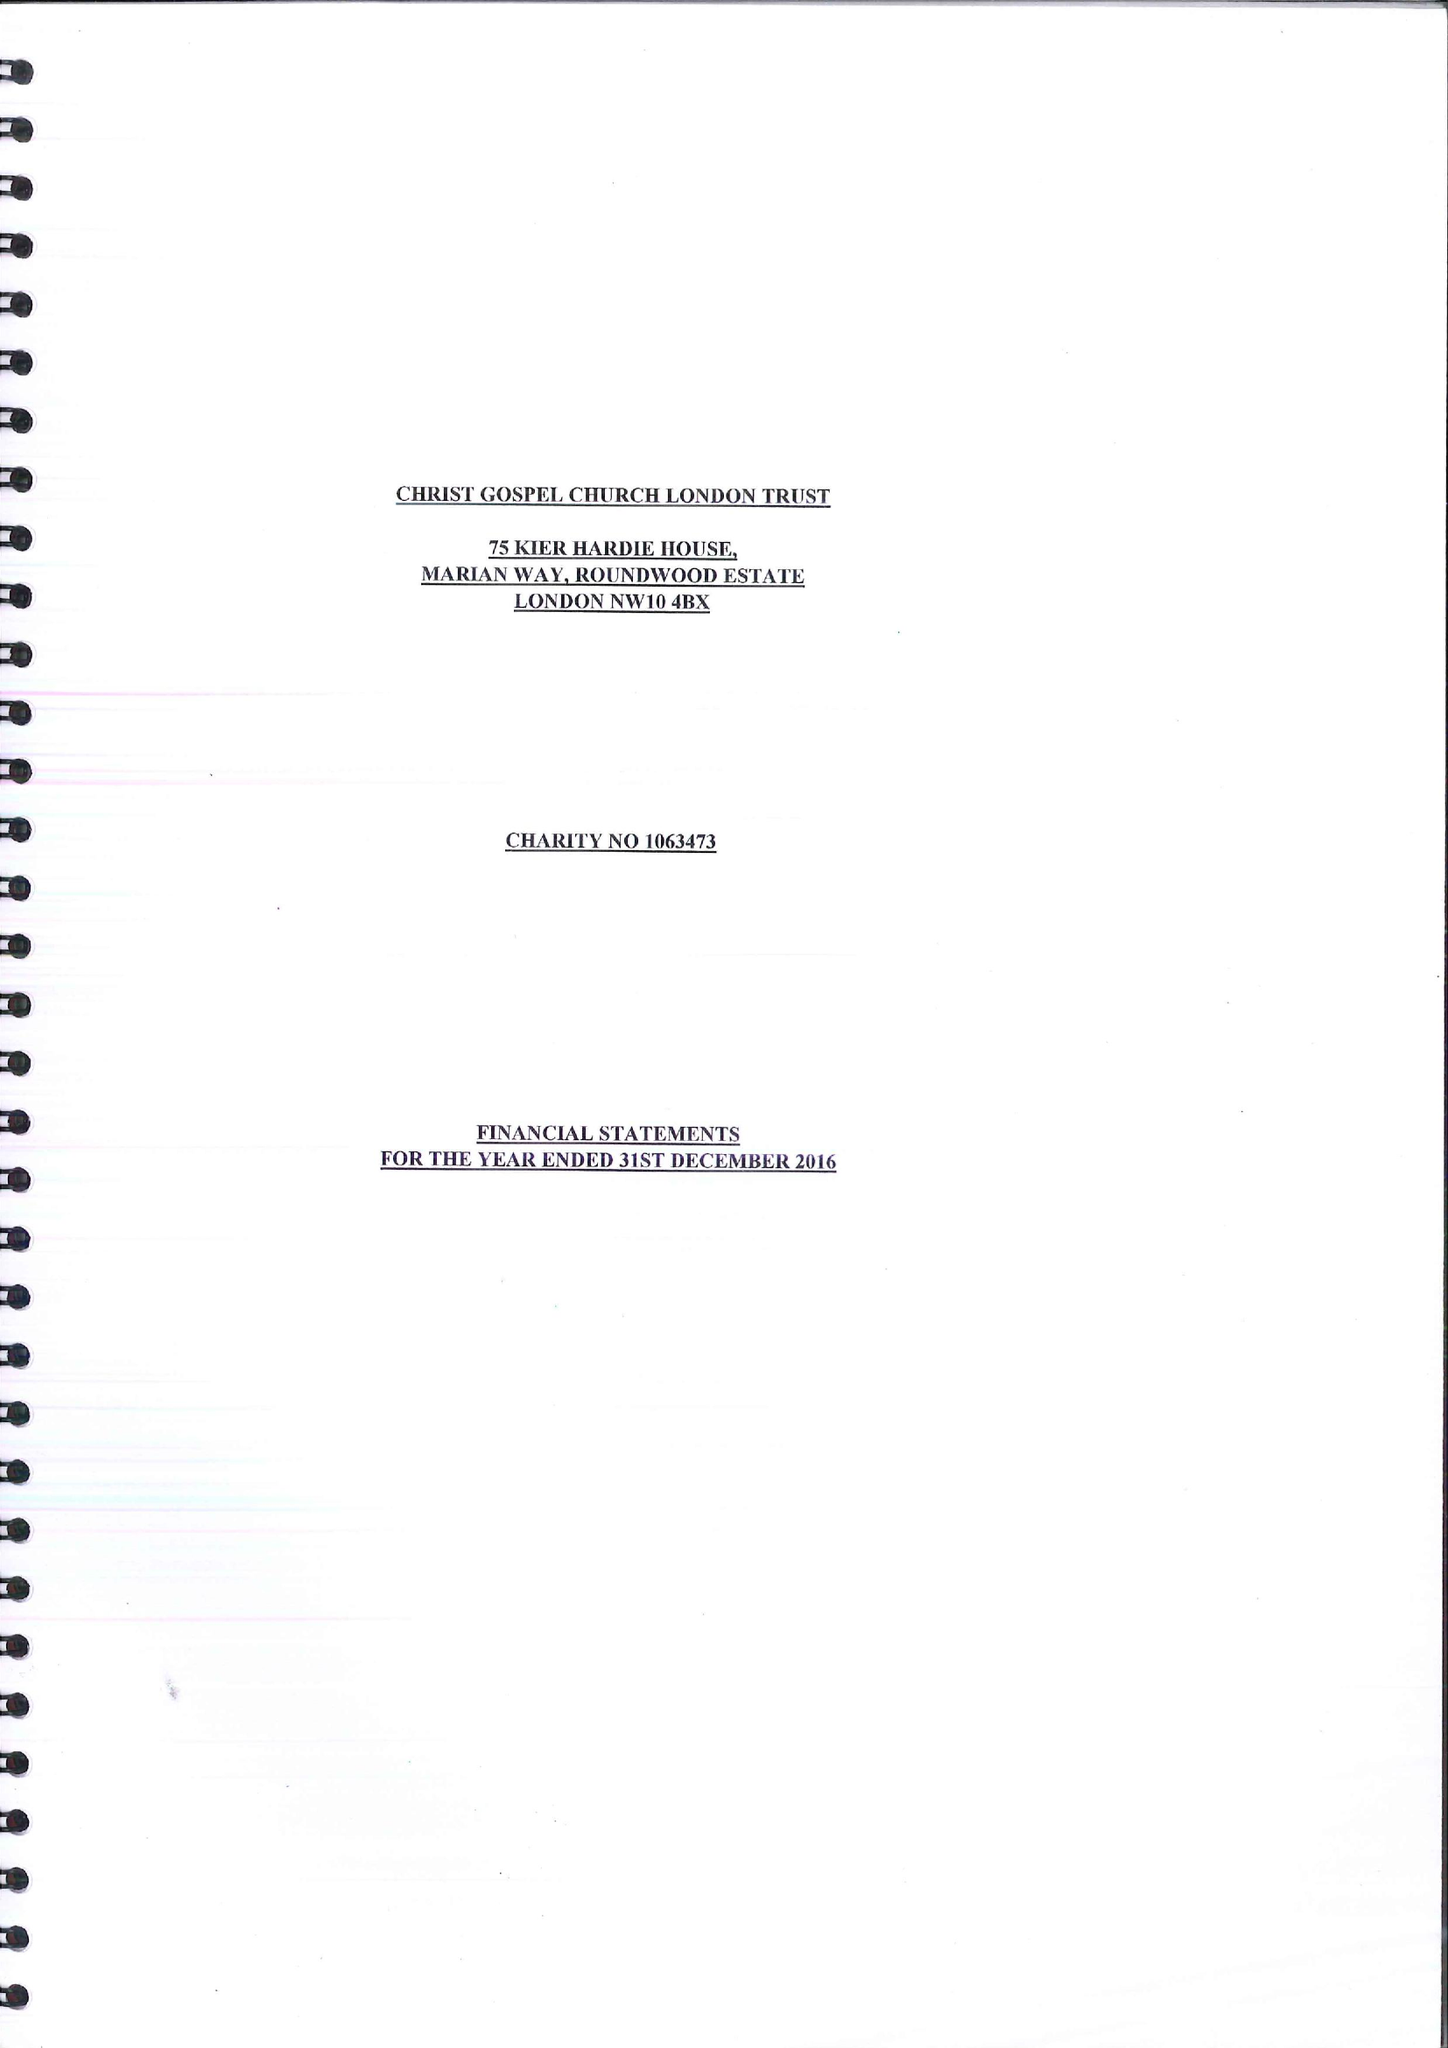What is the value for the charity_name?
Answer the question using a single word or phrase. Christ Gospel Church London Trust 